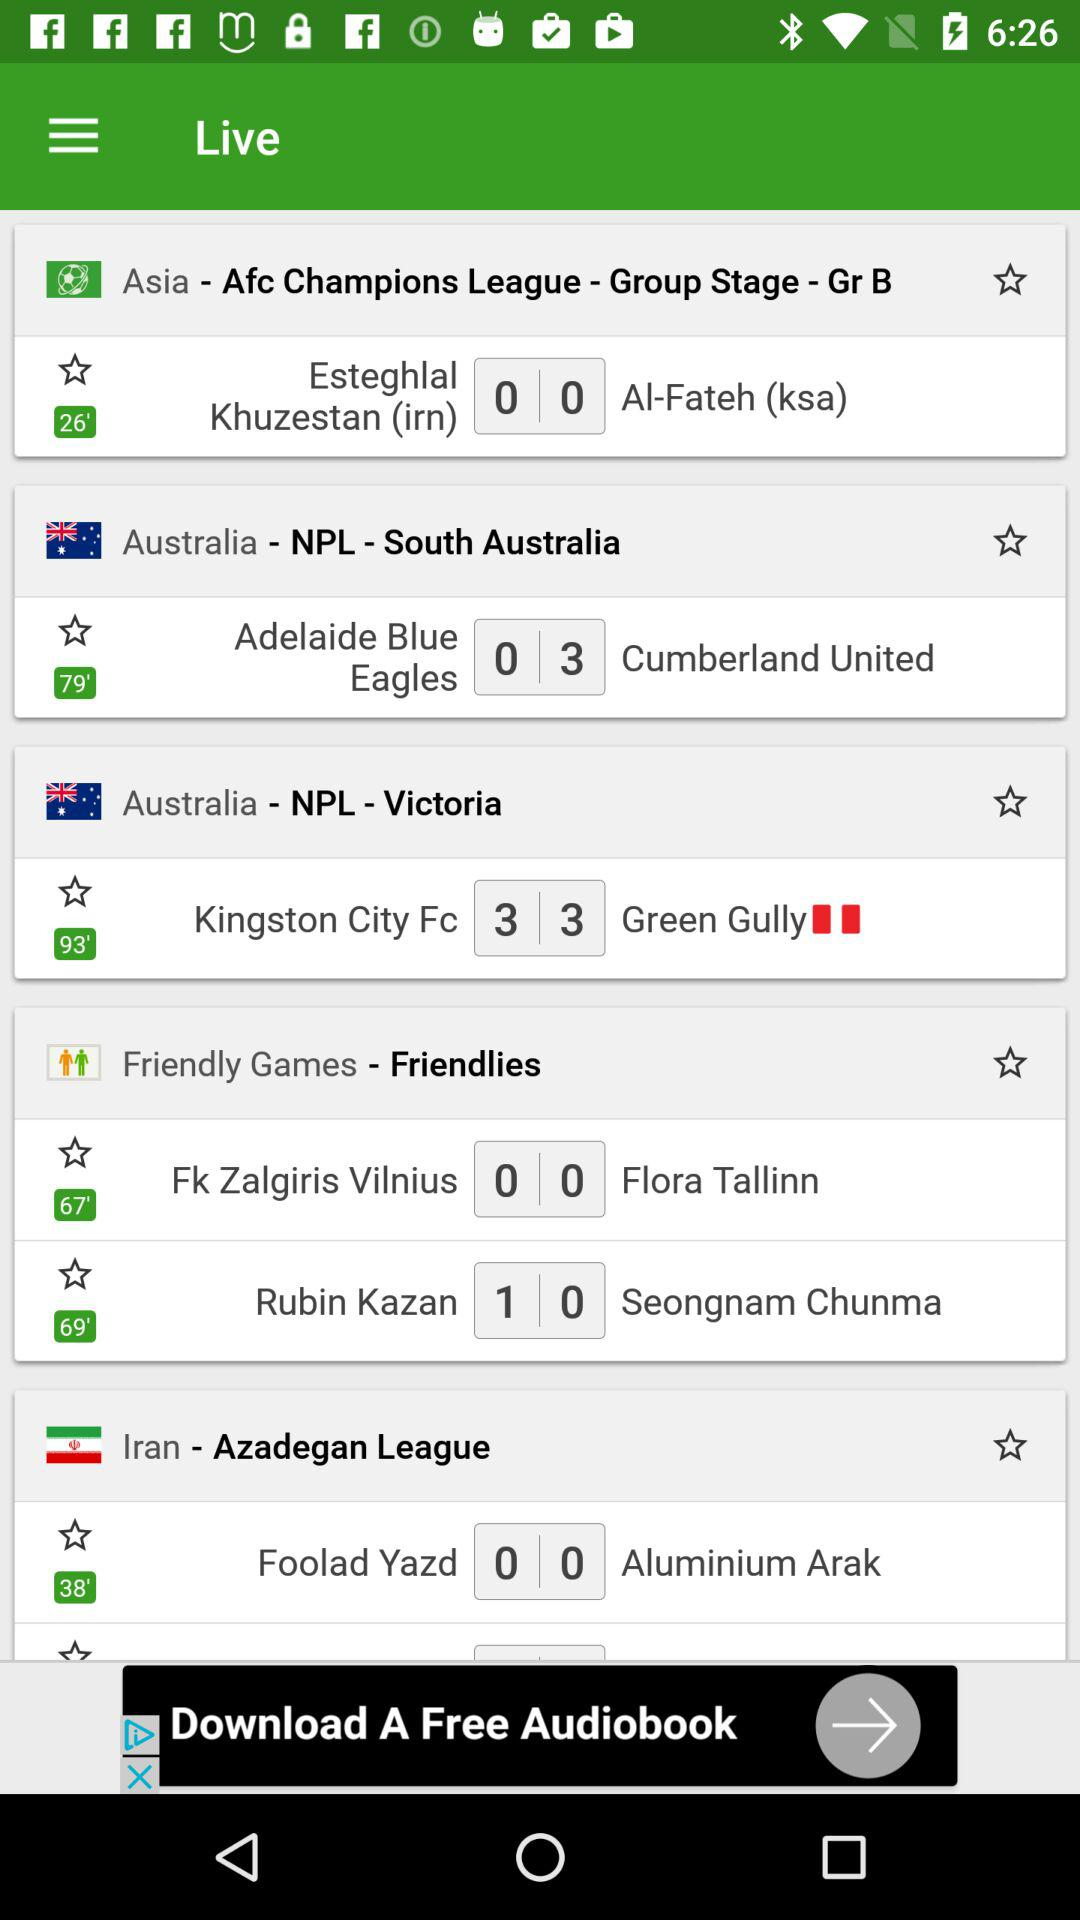What two teams played in the AFC Champions League? The two teams are "Esteghlal Khuzestan (irn)" and "Al-Fateh (ksa)". 